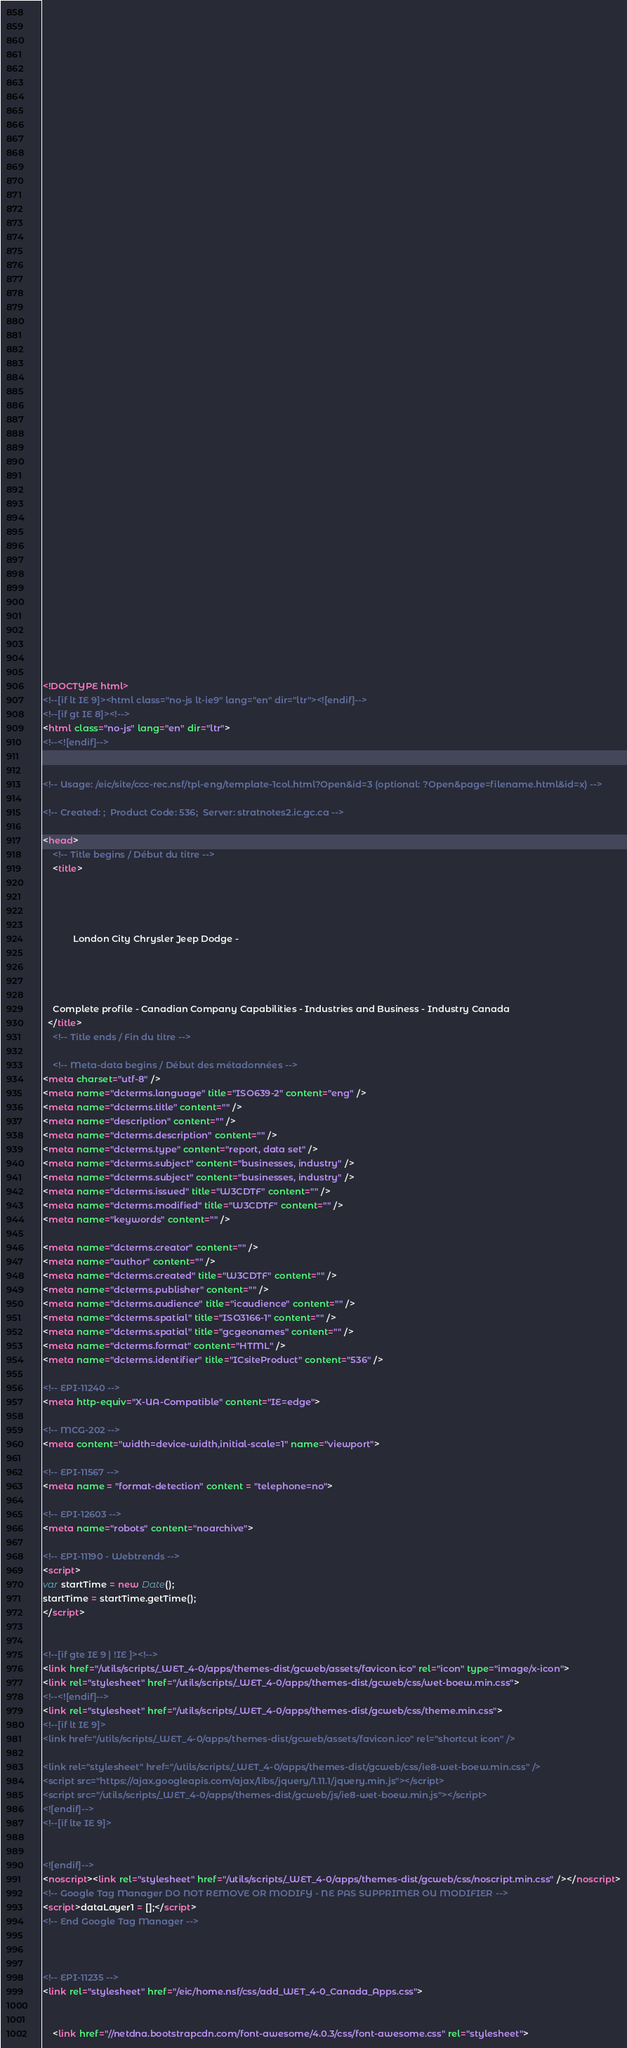Convert code to text. <code><loc_0><loc_0><loc_500><loc_500><_HTML_>


















	






  
  
  
  































	
	
	



<!DOCTYPE html>
<!--[if lt IE 9]><html class="no-js lt-ie9" lang="en" dir="ltr"><![endif]-->
<!--[if gt IE 8]><!-->
<html class="no-js" lang="en" dir="ltr">
<!--<![endif]-->


<!-- Usage: /eic/site/ccc-rec.nsf/tpl-eng/template-1col.html?Open&id=3 (optional: ?Open&page=filename.html&id=x) -->

<!-- Created: ;  Product Code: 536;  Server: stratnotes2.ic.gc.ca -->

<head>
	<!-- Title begins / Début du titre -->
	<title>
    
            
        
          
            London City Chrysler Jeep Dodge -
          
        
      
    
    Complete profile - Canadian Company Capabilities - Industries and Business - Industry Canada
  </title>
	<!-- Title ends / Fin du titre -->
 
	<!-- Meta-data begins / Début des métadonnées -->
<meta charset="utf-8" />
<meta name="dcterms.language" title="ISO639-2" content="eng" />
<meta name="dcterms.title" content="" />
<meta name="description" content="" />
<meta name="dcterms.description" content="" />
<meta name="dcterms.type" content="report, data set" />
<meta name="dcterms.subject" content="businesses, industry" />
<meta name="dcterms.subject" content="businesses, industry" />
<meta name="dcterms.issued" title="W3CDTF" content="" />
<meta name="dcterms.modified" title="W3CDTF" content="" />
<meta name="keywords" content="" />

<meta name="dcterms.creator" content="" />
<meta name="author" content="" />
<meta name="dcterms.created" title="W3CDTF" content="" />
<meta name="dcterms.publisher" content="" />
<meta name="dcterms.audience" title="icaudience" content="" />
<meta name="dcterms.spatial" title="ISO3166-1" content="" />
<meta name="dcterms.spatial" title="gcgeonames" content="" />
<meta name="dcterms.format" content="HTML" />
<meta name="dcterms.identifier" title="ICsiteProduct" content="536" />

<!-- EPI-11240 -->
<meta http-equiv="X-UA-Compatible" content="IE=edge">

<!-- MCG-202 -->
<meta content="width=device-width,initial-scale=1" name="viewport">

<!-- EPI-11567 -->
<meta name = "format-detection" content = "telephone=no">

<!-- EPI-12603 -->
<meta name="robots" content="noarchive">

<!-- EPI-11190 - Webtrends -->
<script>
var startTime = new Date();
startTime = startTime.getTime();
</script>


<!--[if gte IE 9 | !IE ]><!-->
<link href="/utils/scripts/_WET_4-0/apps/themes-dist/gcweb/assets/favicon.ico" rel="icon" type="image/x-icon">
<link rel="stylesheet" href="/utils/scripts/_WET_4-0/apps/themes-dist/gcweb/css/wet-boew.min.css">
<!--<![endif]-->
<link rel="stylesheet" href="/utils/scripts/_WET_4-0/apps/themes-dist/gcweb/css/theme.min.css">
<!--[if lt IE 9]>
<link href="/utils/scripts/_WET_4-0/apps/themes-dist/gcweb/assets/favicon.ico" rel="shortcut icon" />

<link rel="stylesheet" href="/utils/scripts/_WET_4-0/apps/themes-dist/gcweb/css/ie8-wet-boew.min.css" />
<script src="https://ajax.googleapis.com/ajax/libs/jquery/1.11.1/jquery.min.js"></script>
<script src="/utils/scripts/_WET_4-0/apps/themes-dist/gcweb/js/ie8-wet-boew.min.js"></script>
<![endif]-->
<!--[if lte IE 9]>


<![endif]-->
<noscript><link rel="stylesheet" href="/utils/scripts/_WET_4-0/apps/themes-dist/gcweb/css/noscript.min.css" /></noscript>
<!-- Google Tag Manager DO NOT REMOVE OR MODIFY - NE PAS SUPPRIMER OU MODIFIER -->
<script>dataLayer1 = [];</script>
<!-- End Google Tag Manager -->



<!-- EPI-11235 -->
<link rel="stylesheet" href="/eic/home.nsf/css/add_WET_4-0_Canada_Apps.css">


  	<link href="//netdna.bootstrapcdn.com/font-awesome/4.0.3/css/font-awesome.css" rel="stylesheet"></code> 